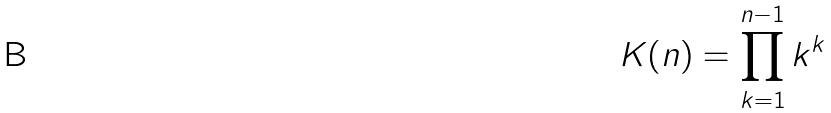<formula> <loc_0><loc_0><loc_500><loc_500>K ( n ) = \prod _ { k = 1 } ^ { n - 1 } k ^ { k }</formula> 